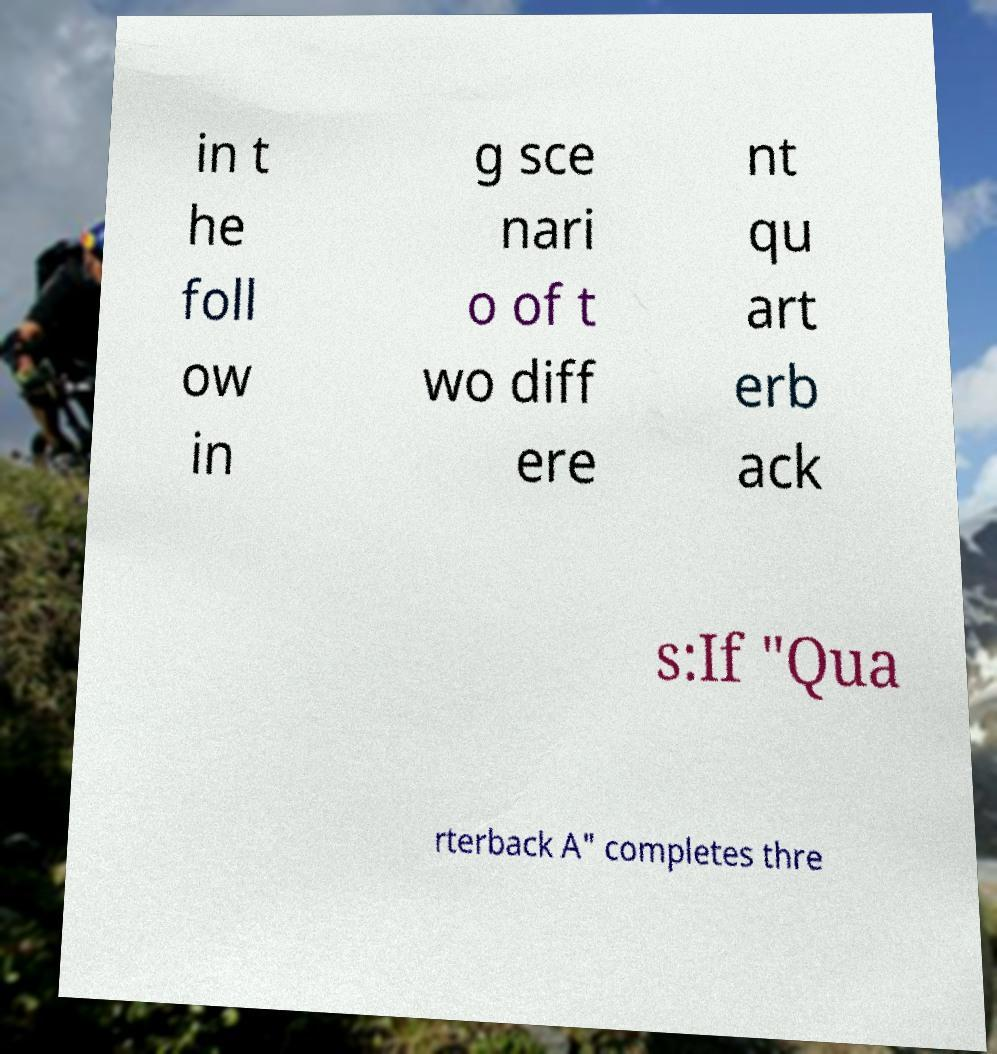Could you extract and type out the text from this image? in t he foll ow in g sce nari o of t wo diff ere nt qu art erb ack s:If "Qua rterback A" completes thre 